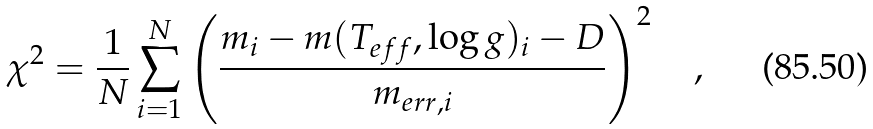<formula> <loc_0><loc_0><loc_500><loc_500>\chi ^ { 2 } = \frac { 1 } { N } \sum _ { i = 1 } ^ { N } \left ( \frac { m _ { i } - m ( T _ { e f f } , \log { g } ) _ { i } - D } { m _ { e r r , i } } \right ) ^ { 2 } \quad ,</formula> 